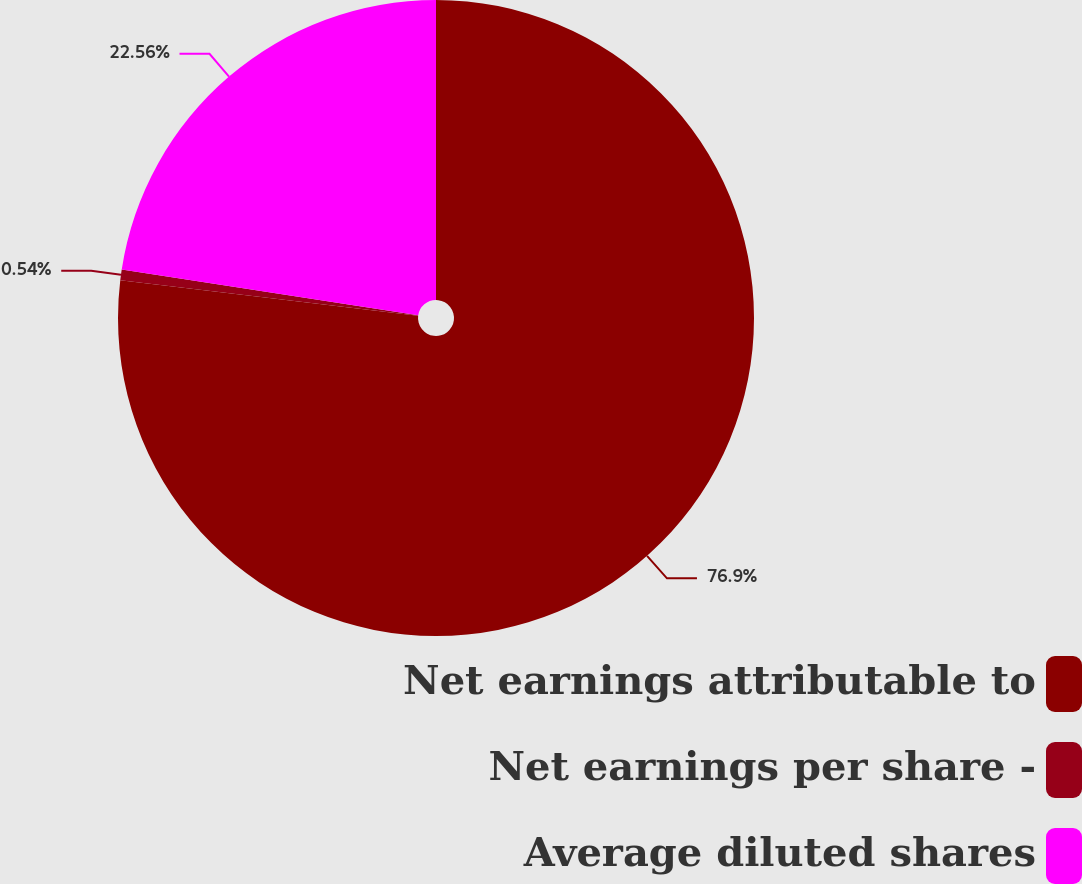<chart> <loc_0><loc_0><loc_500><loc_500><pie_chart><fcel>Net earnings attributable to<fcel>Net earnings per share -<fcel>Average diluted shares<nl><fcel>76.9%<fcel>0.54%<fcel>22.56%<nl></chart> 